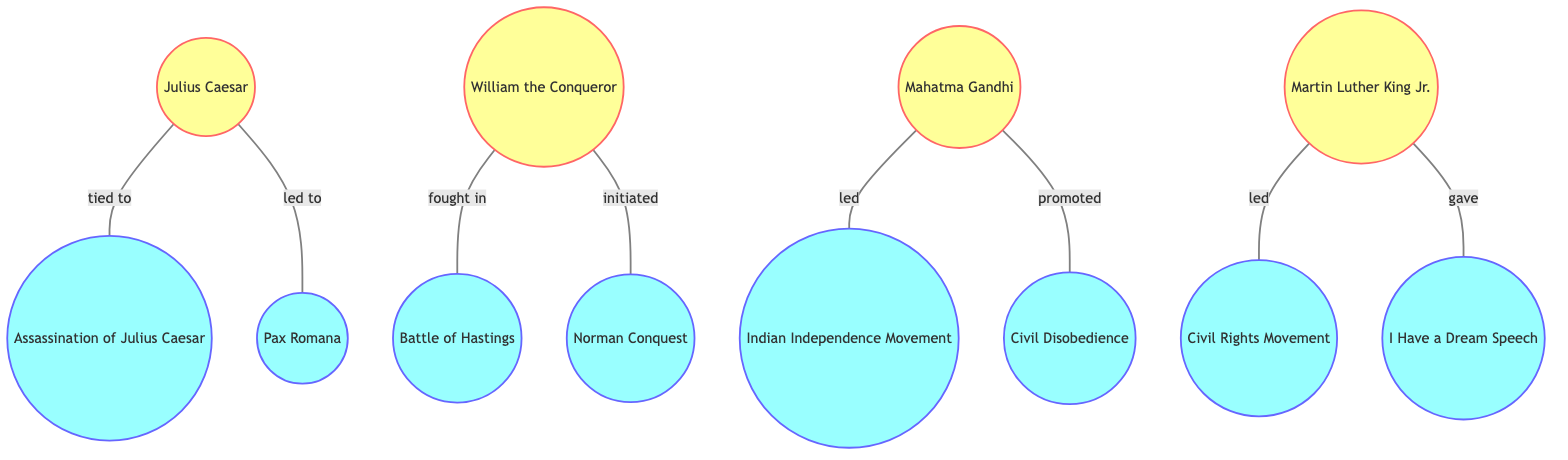What major event is tied to Julius Caesar? The diagram shows an edge labeled "tied to" connecting Julius Caesar to the node representing the "Assassination of Julius Caesar." This indicates that his assassination is a major event related to him.
Answer: Assassination of Julius Caesar How many nodes are there in the diagram? To determine the number of nodes, count each unique historical figure and event in the diagram. There are 11 total nodes: four historical figures and seven events.
Answer: 11 Who led the Indian Independence Movement? The diagram indicates that Mahatma Gandhi is connected to the Indian Independence Movement by an edge labeled "led." Therefore, he is identified as the leader of this movement.
Answer: Mahatma Gandhi Which historical figure promoted Civil Disobedience? According to the diagram, there is an edge labeled "promoted" connecting Mahatma Gandhi to the Civil Disobedience node. This shows that he played a significant role in promoting this concept.
Answer: Mahatma Gandhi What is the relationship between Martin Luther King Jr. and the Civil Rights Movement? The diagram shows that Martin Luther King Jr. is connected to the Civil Rights Movement through the edge labeled "led." This means he was a key leader of this movement.
Answer: led What major event did William the Conqueror fight in? An edge labeled "fought in" connects William the Conqueror to the Battle of Hastings. This indicates that the Battle of Hastings is a significant event associated with him.
Answer: Battle of Hastings Which event followed Julius Caesar's leadership in Rome? The edge labeled "led to" connects Julius Caesar to the Pax Romana. This connection indicates that his actions led to the establishment of this significant period of peace in Rome.
Answer: Pax Romana How many edges are in this graph? To find the number of edges, count each connection between nodes. There are 8 edges in total, which represent the relationships between the historical figures and events.
Answer: 8 What speech did Martin Luther King Jr. give? The edge labeled "gave" connects Martin Luther King Jr. to the I Have a Dream Speech node, indicating that he is recognized for delivering this influential speech.
Answer: I Have a Dream Speech 